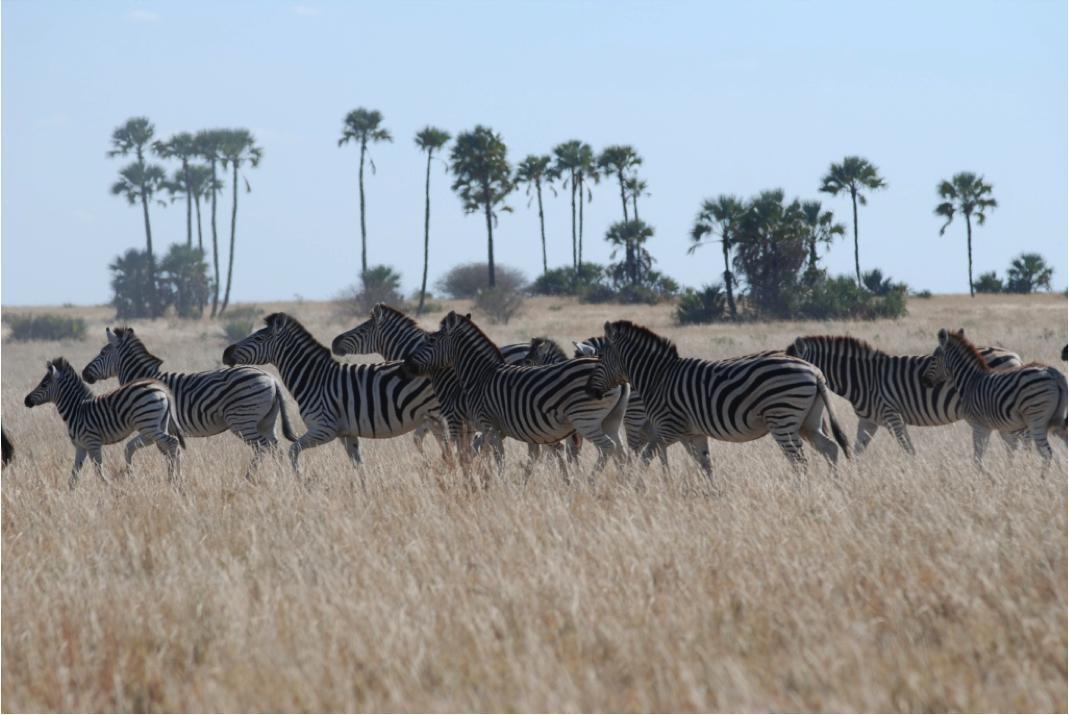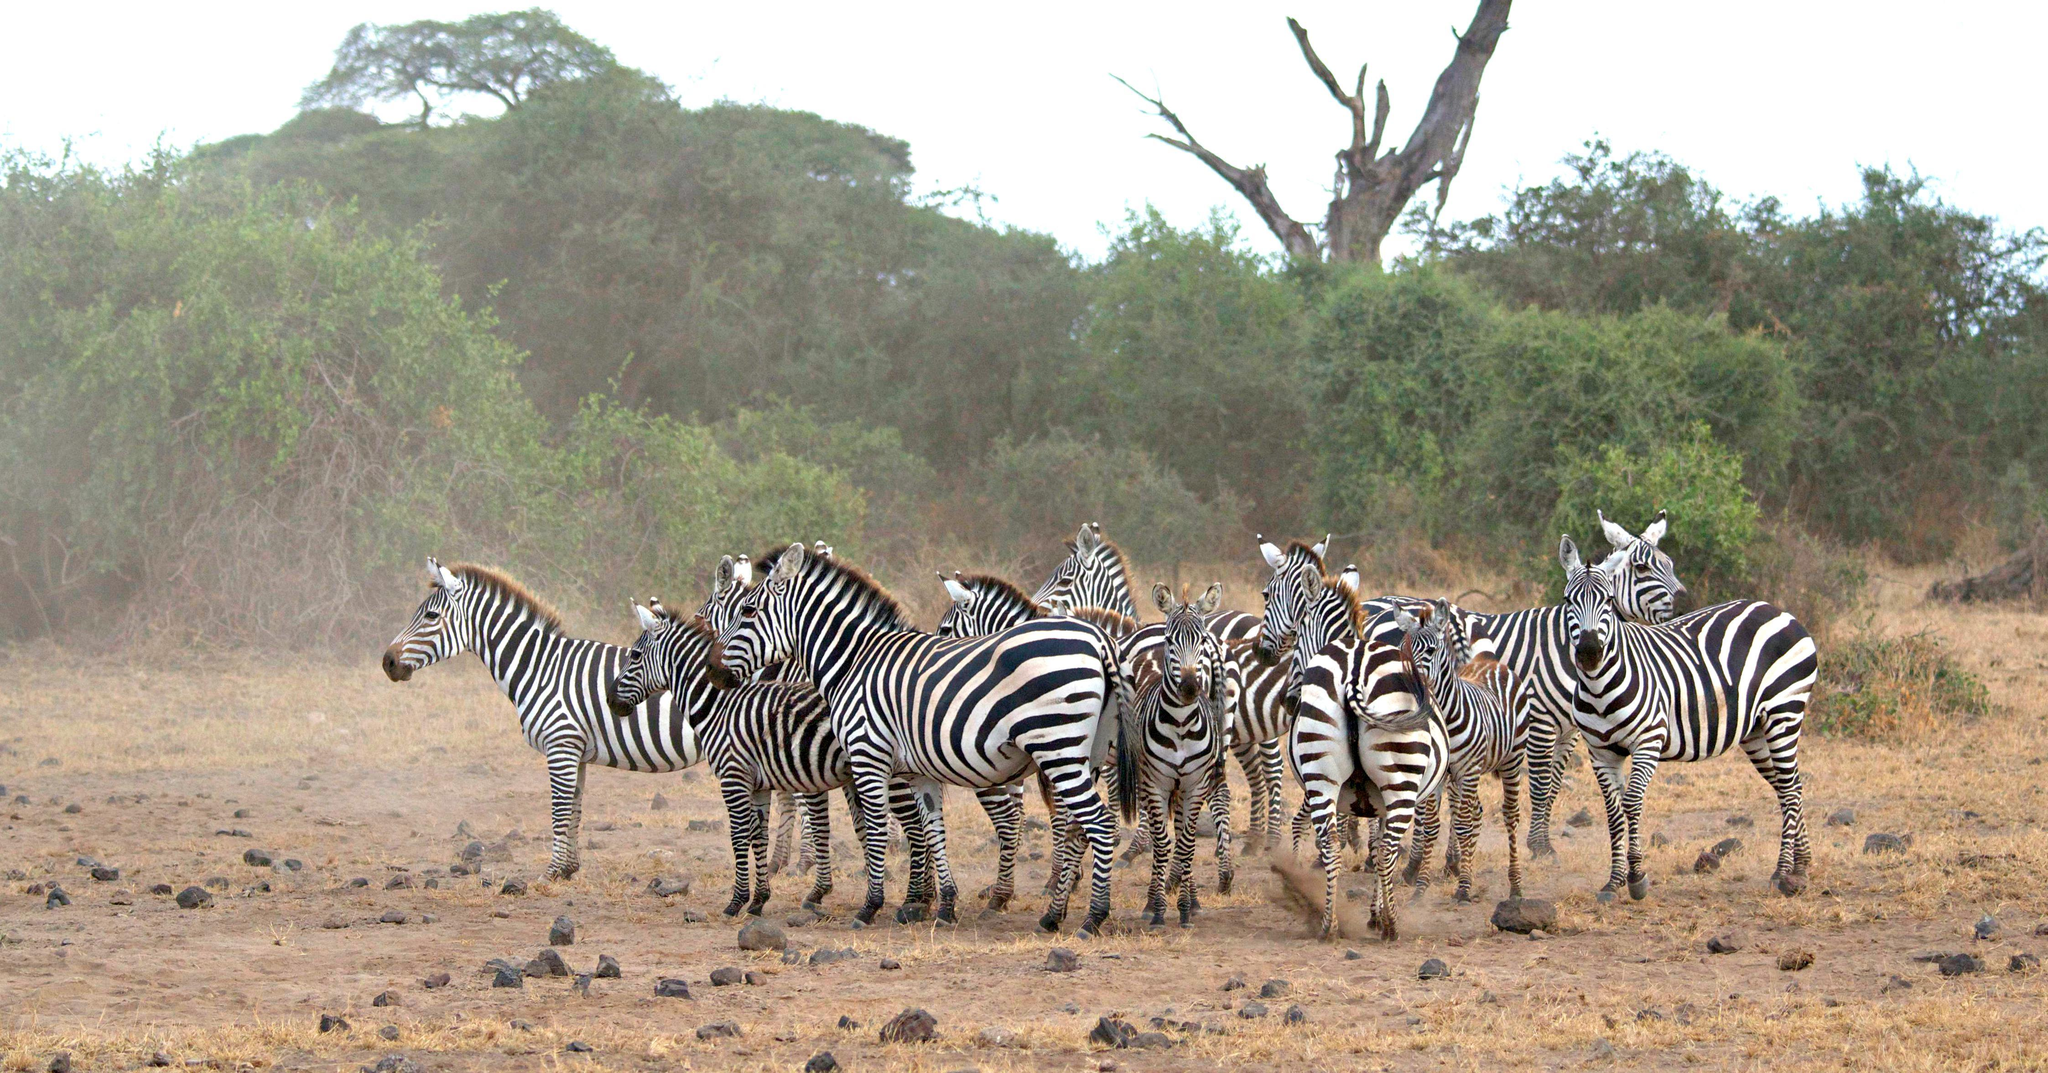The first image is the image on the left, the second image is the image on the right. For the images displayed, is the sentence "There are three zebras" factually correct? Answer yes or no. No. 